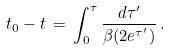<formula> <loc_0><loc_0><loc_500><loc_500>t _ { 0 } - t \, = \, \int _ { 0 } ^ { \tau } \frac { d \tau ^ { \prime } } { \beta ( 2 e ^ { \tau ^ { \prime } } ) } \, .</formula> 